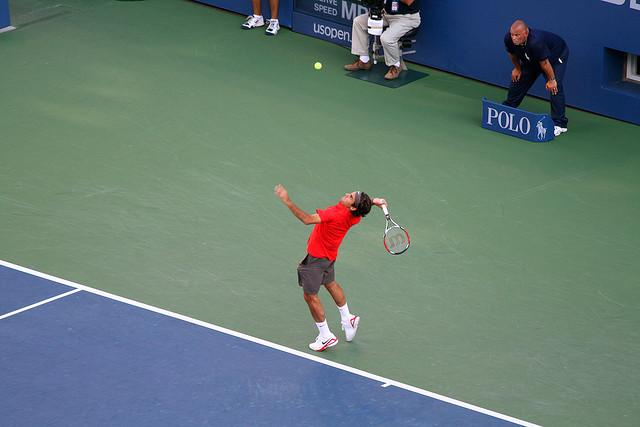What part of tennis is happening? Please explain your reasoning. serve. The player's body is in the position to serve. 